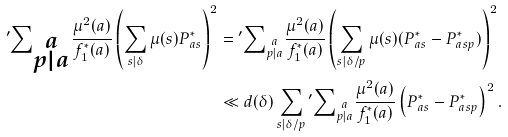Convert formula to latex. <formula><loc_0><loc_0><loc_500><loc_500>{ ^ { \prime } } { \sum } _ { \substack { a \\ p | a } } \frac { \mu ^ { 2 } ( a ) } { f _ { 1 } ^ { * } ( a ) } \left ( \sum _ { s | \delta } \mu ( s ) P _ { a s } ^ { * } \right ) ^ { 2 } & = { ^ { \prime } } { \sum } _ { \substack { a \\ p | a } } \frac { \mu ^ { 2 } ( a ) } { f _ { 1 } ^ { * } ( a ) } \left ( \sum _ { s | \delta / p } \mu ( s ) ( P _ { a s } ^ { * } - P _ { a s p } ^ { * } ) \right ) ^ { 2 } \\ & \ll d ( \delta ) \sum _ { s | \delta / p } { ^ { \prime } } { \sum } _ { \substack { a \\ p | a } } \frac { \mu ^ { 2 } ( a ) } { f _ { 1 } ^ { * } ( a ) } \left ( P _ { a s } ^ { * } - P ^ { * } _ { a s p } \right ) ^ { 2 } .</formula> 